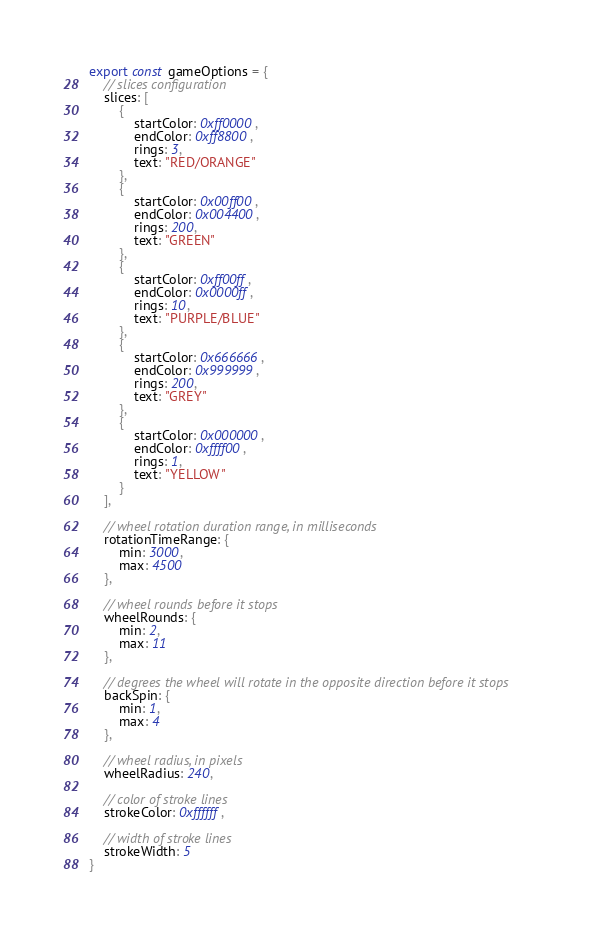<code> <loc_0><loc_0><loc_500><loc_500><_TypeScript_>export const gameOptions = {
    // slices configuration
    slices: [
        {
            startColor: 0xff0000,
            endColor: 0xff8800,
            rings: 3,
            text: "RED/ORANGE"
        },
        {
            startColor: 0x00ff00,
            endColor: 0x004400,
            rings: 200,
            text: "GREEN"
        },
        {
            startColor: 0xff00ff,
            endColor: 0x0000ff,
            rings: 10,
            text: "PURPLE/BLUE"
        },
        {
            startColor: 0x666666,
            endColor: 0x999999,
            rings: 200,
            text: "GREY"
        },
        {
            startColor: 0x000000,
            endColor: 0xffff00,
            rings: 1,
            text: "YELLOW"
        }
    ],

    // wheel rotation duration range, in milliseconds
    rotationTimeRange: {
        min: 3000,
        max: 4500
    },

    // wheel rounds before it stops
    wheelRounds: {
        min: 2,
        max: 11
    },

    // degrees the wheel will rotate in the opposite direction before it stops
    backSpin: {
        min: 1,
        max: 4
    },

    // wheel radius, in pixels
    wheelRadius: 240,

    // color of stroke lines
    strokeColor: 0xffffff,

    // width of stroke lines
    strokeWidth: 5
}</code> 